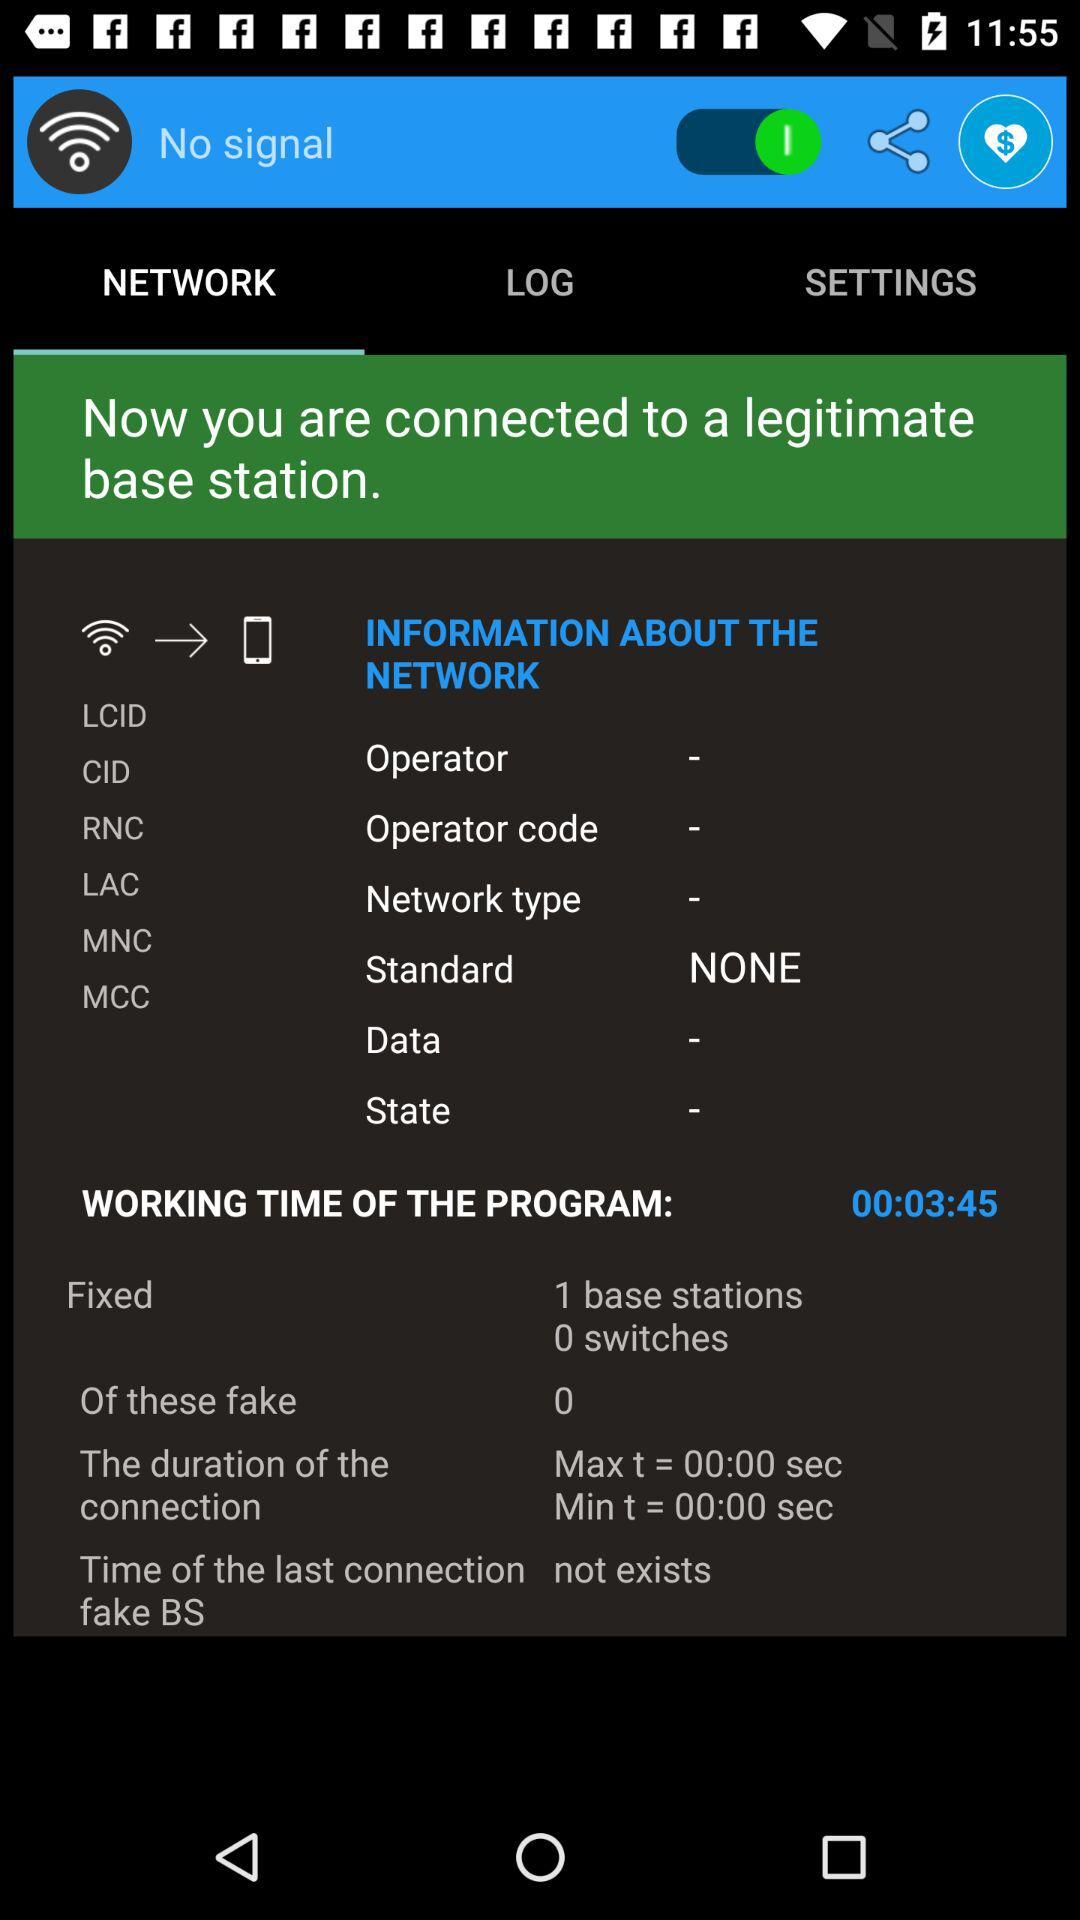How many base stations and switches are there? There is 1 base station and 0 switches. 